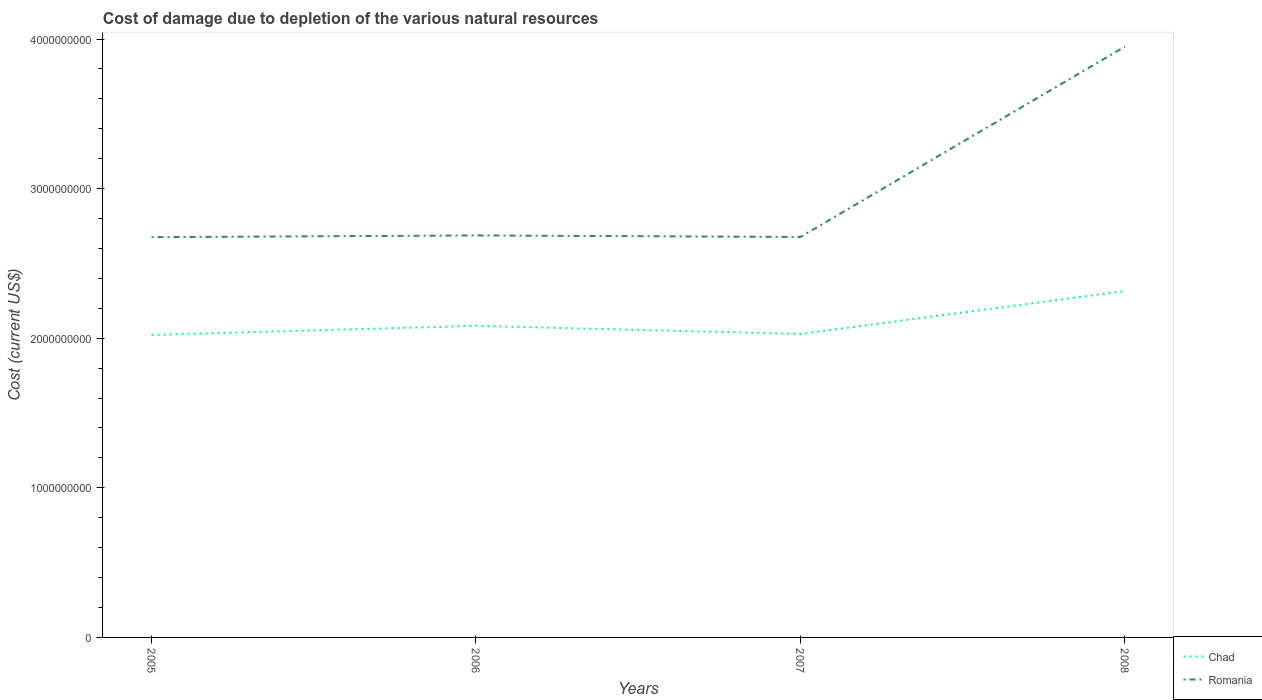Is the number of lines equal to the number of legend labels?
Offer a very short reply. Yes. Across all years, what is the maximum cost of damage caused due to the depletion of various natural resources in Chad?
Your response must be concise. 2.02e+09. What is the total cost of damage caused due to the depletion of various natural resources in Romania in the graph?
Offer a very short reply. -1.27e+09. What is the difference between the highest and the second highest cost of damage caused due to the depletion of various natural resources in Romania?
Offer a very short reply. 1.27e+09. What is the difference between the highest and the lowest cost of damage caused due to the depletion of various natural resources in Chad?
Your answer should be compact. 1. How many lines are there?
Offer a very short reply. 2. Are the values on the major ticks of Y-axis written in scientific E-notation?
Provide a succinct answer. No. Does the graph contain any zero values?
Ensure brevity in your answer.  No. Does the graph contain grids?
Your response must be concise. No. Where does the legend appear in the graph?
Offer a very short reply. Bottom right. How many legend labels are there?
Your answer should be compact. 2. How are the legend labels stacked?
Offer a terse response. Vertical. What is the title of the graph?
Offer a very short reply. Cost of damage due to depletion of the various natural resources. Does "Serbia" appear as one of the legend labels in the graph?
Offer a terse response. No. What is the label or title of the X-axis?
Provide a succinct answer. Years. What is the label or title of the Y-axis?
Ensure brevity in your answer.  Cost (current US$). What is the Cost (current US$) of Chad in 2005?
Ensure brevity in your answer.  2.02e+09. What is the Cost (current US$) in Romania in 2005?
Make the answer very short. 2.68e+09. What is the Cost (current US$) of Chad in 2006?
Ensure brevity in your answer.  2.08e+09. What is the Cost (current US$) of Romania in 2006?
Make the answer very short. 2.69e+09. What is the Cost (current US$) in Chad in 2007?
Make the answer very short. 2.03e+09. What is the Cost (current US$) in Romania in 2007?
Give a very brief answer. 2.68e+09. What is the Cost (current US$) in Chad in 2008?
Ensure brevity in your answer.  2.32e+09. What is the Cost (current US$) of Romania in 2008?
Provide a short and direct response. 3.95e+09. Across all years, what is the maximum Cost (current US$) in Chad?
Your response must be concise. 2.32e+09. Across all years, what is the maximum Cost (current US$) of Romania?
Your answer should be very brief. 3.95e+09. Across all years, what is the minimum Cost (current US$) of Chad?
Offer a very short reply. 2.02e+09. Across all years, what is the minimum Cost (current US$) in Romania?
Your answer should be compact. 2.68e+09. What is the total Cost (current US$) in Chad in the graph?
Provide a short and direct response. 8.45e+09. What is the total Cost (current US$) of Romania in the graph?
Ensure brevity in your answer.  1.20e+1. What is the difference between the Cost (current US$) of Chad in 2005 and that in 2006?
Offer a terse response. -6.07e+07. What is the difference between the Cost (current US$) of Romania in 2005 and that in 2006?
Your response must be concise. -1.15e+07. What is the difference between the Cost (current US$) of Chad in 2005 and that in 2007?
Keep it short and to the point. -6.30e+06. What is the difference between the Cost (current US$) in Romania in 2005 and that in 2007?
Your answer should be very brief. -1.26e+06. What is the difference between the Cost (current US$) in Chad in 2005 and that in 2008?
Ensure brevity in your answer.  -2.93e+08. What is the difference between the Cost (current US$) in Romania in 2005 and that in 2008?
Offer a terse response. -1.27e+09. What is the difference between the Cost (current US$) of Chad in 2006 and that in 2007?
Give a very brief answer. 5.44e+07. What is the difference between the Cost (current US$) of Romania in 2006 and that in 2007?
Your answer should be very brief. 1.02e+07. What is the difference between the Cost (current US$) in Chad in 2006 and that in 2008?
Your answer should be very brief. -2.32e+08. What is the difference between the Cost (current US$) of Romania in 2006 and that in 2008?
Your answer should be compact. -1.26e+09. What is the difference between the Cost (current US$) of Chad in 2007 and that in 2008?
Give a very brief answer. -2.87e+08. What is the difference between the Cost (current US$) of Romania in 2007 and that in 2008?
Ensure brevity in your answer.  -1.27e+09. What is the difference between the Cost (current US$) of Chad in 2005 and the Cost (current US$) of Romania in 2006?
Keep it short and to the point. -6.65e+08. What is the difference between the Cost (current US$) in Chad in 2005 and the Cost (current US$) in Romania in 2007?
Provide a short and direct response. -6.55e+08. What is the difference between the Cost (current US$) in Chad in 2005 and the Cost (current US$) in Romania in 2008?
Make the answer very short. -1.93e+09. What is the difference between the Cost (current US$) in Chad in 2006 and the Cost (current US$) in Romania in 2007?
Your answer should be very brief. -5.94e+08. What is the difference between the Cost (current US$) of Chad in 2006 and the Cost (current US$) of Romania in 2008?
Make the answer very short. -1.87e+09. What is the difference between the Cost (current US$) in Chad in 2007 and the Cost (current US$) in Romania in 2008?
Offer a terse response. -1.92e+09. What is the average Cost (current US$) in Chad per year?
Give a very brief answer. 2.11e+09. What is the average Cost (current US$) of Romania per year?
Offer a very short reply. 3.00e+09. In the year 2005, what is the difference between the Cost (current US$) of Chad and Cost (current US$) of Romania?
Make the answer very short. -6.53e+08. In the year 2006, what is the difference between the Cost (current US$) in Chad and Cost (current US$) in Romania?
Provide a succinct answer. -6.04e+08. In the year 2007, what is the difference between the Cost (current US$) in Chad and Cost (current US$) in Romania?
Keep it short and to the point. -6.48e+08. In the year 2008, what is the difference between the Cost (current US$) of Chad and Cost (current US$) of Romania?
Your answer should be very brief. -1.63e+09. What is the ratio of the Cost (current US$) in Chad in 2005 to that in 2006?
Keep it short and to the point. 0.97. What is the ratio of the Cost (current US$) in Romania in 2005 to that in 2007?
Make the answer very short. 1. What is the ratio of the Cost (current US$) of Chad in 2005 to that in 2008?
Give a very brief answer. 0.87. What is the ratio of the Cost (current US$) in Romania in 2005 to that in 2008?
Offer a very short reply. 0.68. What is the ratio of the Cost (current US$) of Chad in 2006 to that in 2007?
Make the answer very short. 1.03. What is the ratio of the Cost (current US$) of Chad in 2006 to that in 2008?
Offer a very short reply. 0.9. What is the ratio of the Cost (current US$) of Romania in 2006 to that in 2008?
Your answer should be very brief. 0.68. What is the ratio of the Cost (current US$) of Chad in 2007 to that in 2008?
Provide a succinct answer. 0.88. What is the ratio of the Cost (current US$) of Romania in 2007 to that in 2008?
Offer a very short reply. 0.68. What is the difference between the highest and the second highest Cost (current US$) of Chad?
Your answer should be compact. 2.32e+08. What is the difference between the highest and the second highest Cost (current US$) of Romania?
Make the answer very short. 1.26e+09. What is the difference between the highest and the lowest Cost (current US$) of Chad?
Make the answer very short. 2.93e+08. What is the difference between the highest and the lowest Cost (current US$) of Romania?
Offer a terse response. 1.27e+09. 